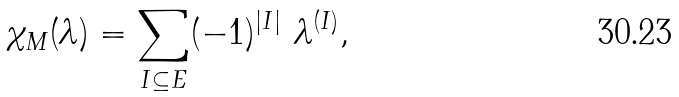Convert formula to latex. <formula><loc_0><loc_0><loc_500><loc_500>\chi _ { M } ( \lambda ) = \sum _ { I \subseteq E } ( - 1 ) ^ { | I | } \ \lambda ^ { ( I ) } ,</formula> 